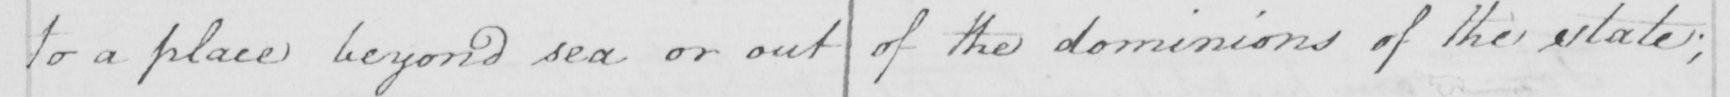What text is written in this handwritten line? to a place beyond sea or out of the dominions of the state ; 